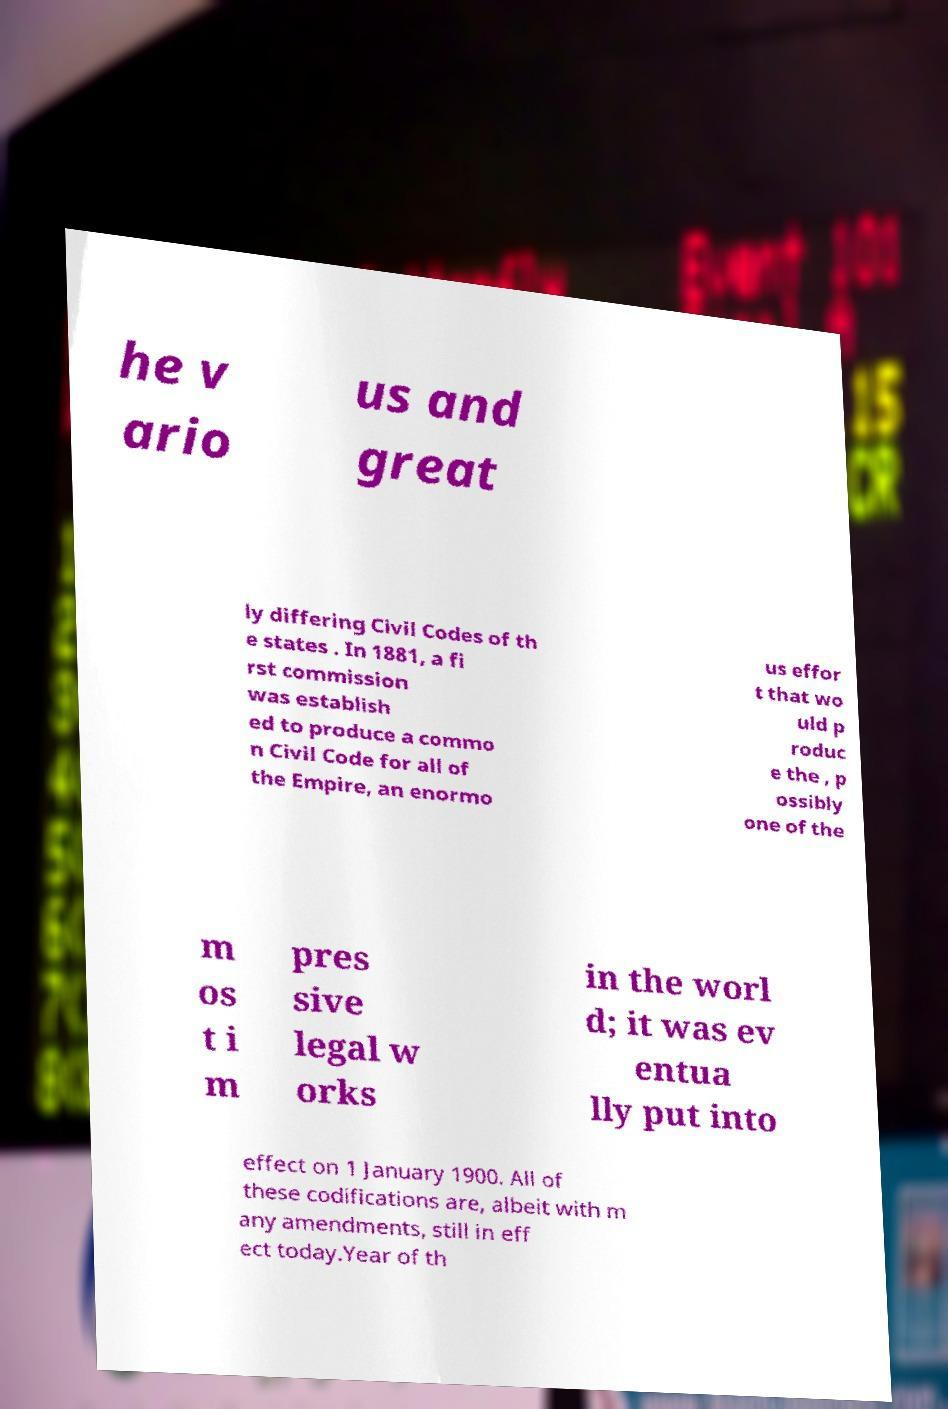Can you accurately transcribe the text from the provided image for me? he v ario us and great ly differing Civil Codes of th e states . In 1881, a fi rst commission was establish ed to produce a commo n Civil Code for all of the Empire, an enormo us effor t that wo uld p roduc e the , p ossibly one of the m os t i m pres sive legal w orks in the worl d; it was ev entua lly put into effect on 1 January 1900. All of these codifications are, albeit with m any amendments, still in eff ect today.Year of th 